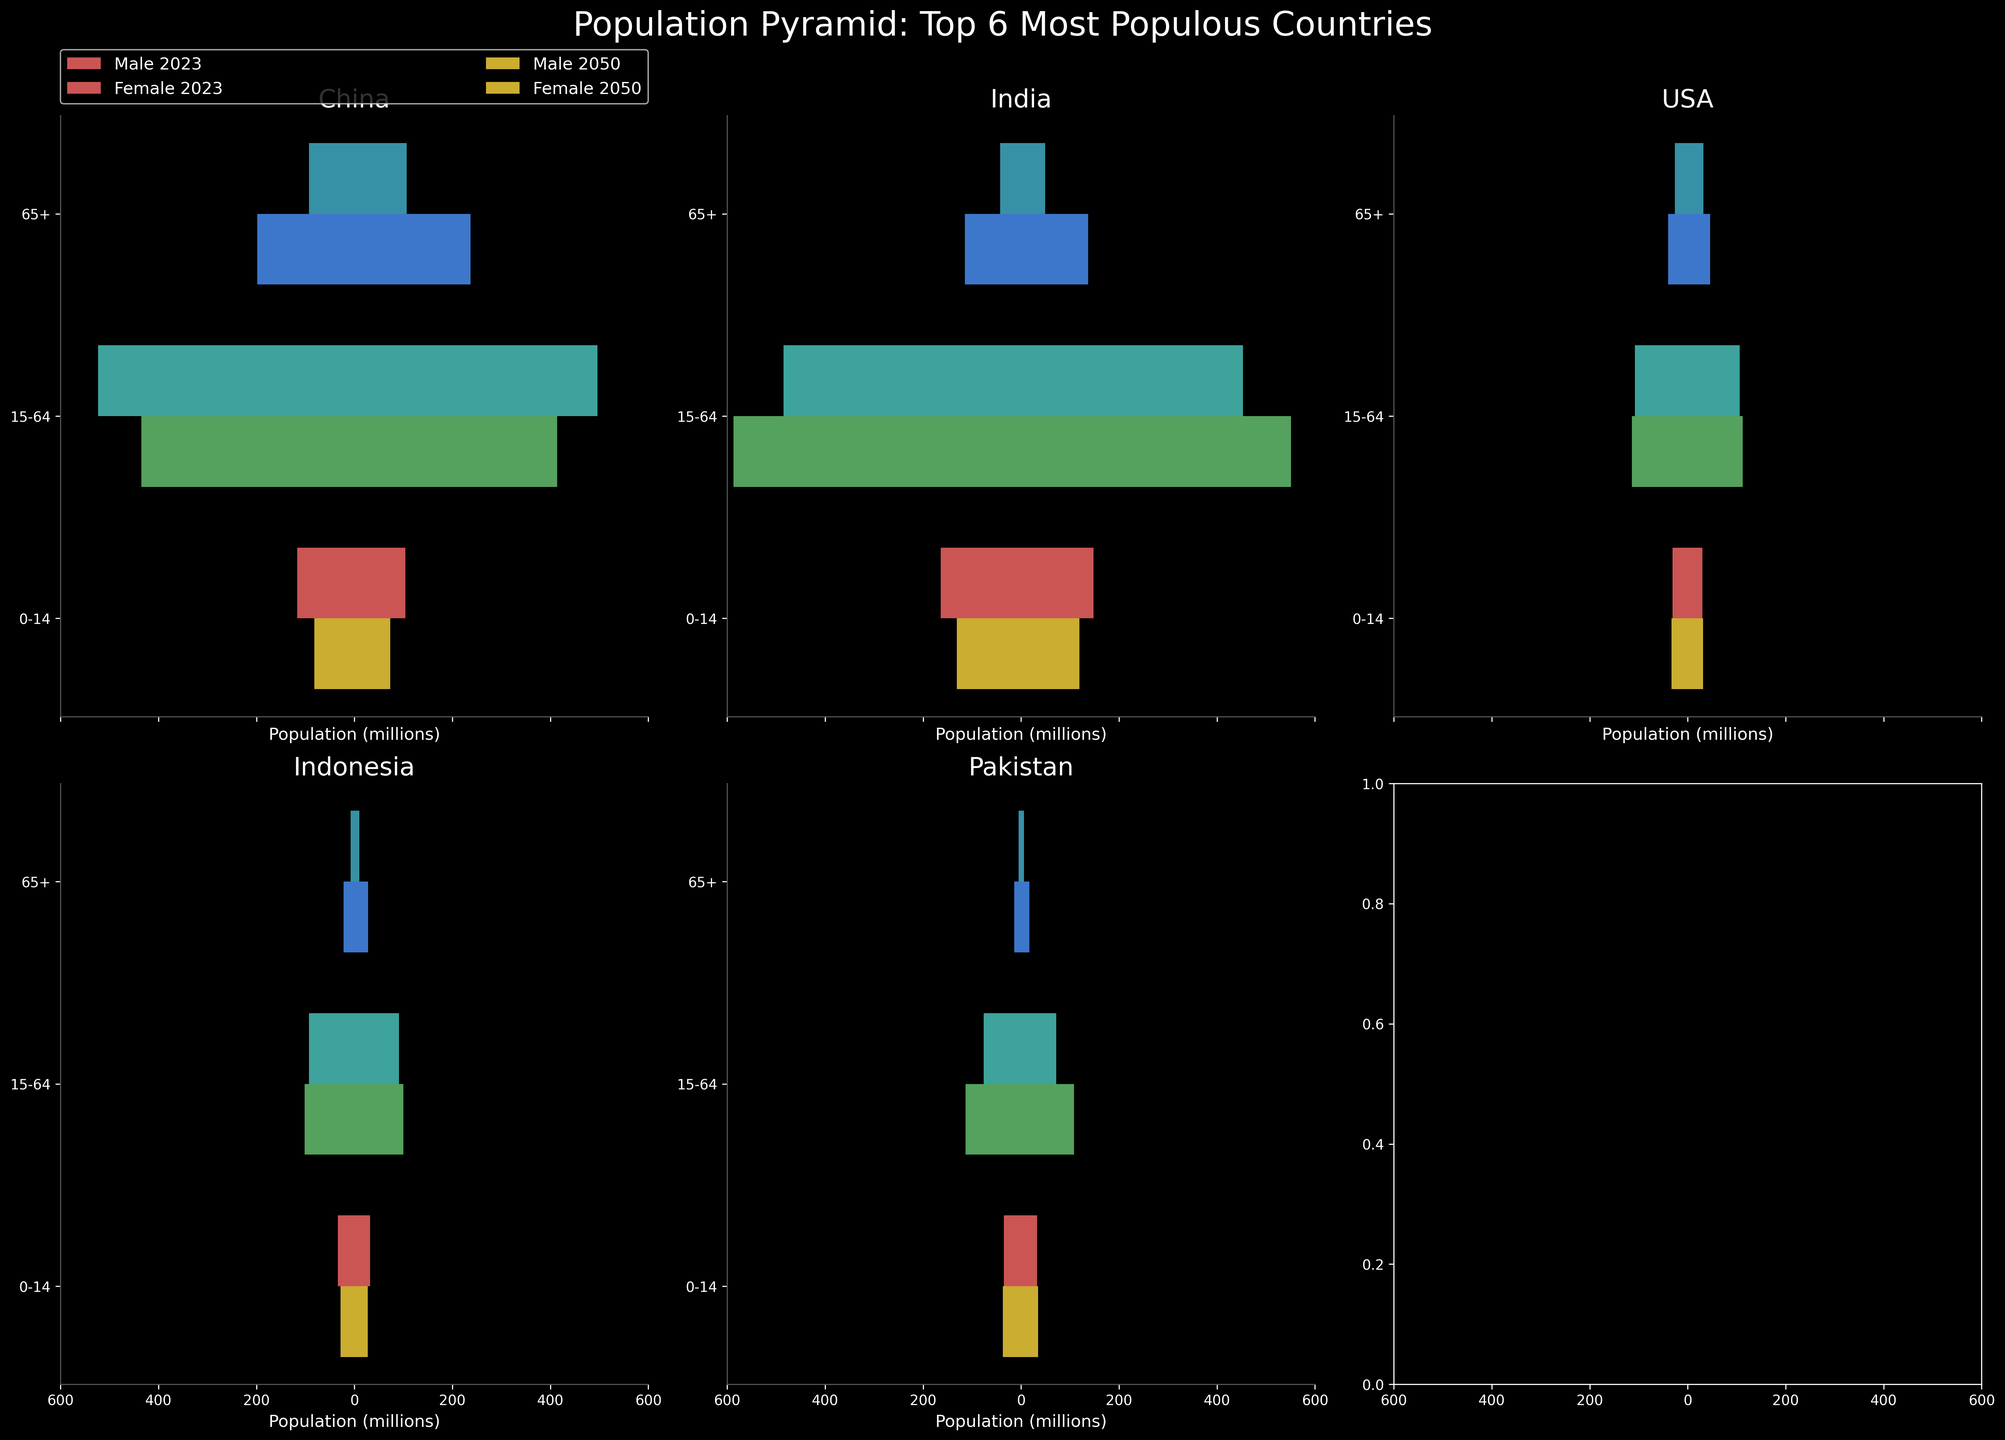What's the title of the figure? The title is centered at the top of the figure. It reads "Population Pyramid: Top 6 Most Populous Countries"
Answer: Population Pyramid: Top 6 Most Populous Countries How many age groups are displayed on the Y-axis? The Y-axis shows the different age groups. By counting the age groups, we see three distinct ones: "0-14", "15-64", and "65+"
Answer: 3 Which country has the highest projected male population aged 65+ in 2050? Among the countries displayed, the height of the bars for "Male 65+" in 2050 can be compared. India shows the tallest negative bar, indicating a higher male population among this age group.
Answer: India What’s the total population of China in 2023 in the age group 15-64? To find the total population, sum the male and female populations in the 15-64 age group for China in 2023. For males, it's 523 million, and for females, it's 496 million. Therefore, the total is 523 + 496 = 1019 million.
Answer: 1019 million Compare the projected populations of the USA in age group 0-14 for 2023 and 2050. Which year has a higher population, and by how much? Looking at the height of the bars for the USA in the 0-14 age group, 2050 has an approximate population of 33 million (males + females) while 2023 shows around 31 million. The difference is 33 - 31 = 2 million.
Answer: 2050, 2 million How does the female population aged 65+ in Pakistan in 2050 compare to that in 2023? Observing the bar lengths for "Female 65+" in Pakistan, the population in 2050 is significantly longer, at around 17 million, compared to only 6 million in 2023.
Answer: 2050 is higher by 11 million What trends can you observe in the aging population (65+) of China from 2023 to 2050? Comparing the heights of the bars for "65+" from 2023 to 2050 for China reveals that the population for both males and females significantly increases, indicating an aging population over time.
Answer: Increasing trend In which year does Indonesia have a higher male population in the age group 15-64, and by how much? By comparing the bar lengths for males aged 15-64 in Indonesia, the population in 2050 is about 102 million, whereas in 2023, it's around 93 million. The difference is 102 - 93 = 9 million.
Answer: 2050, by 9 million Which country has the smallest projected youth (0-14) population in 2050? By comparing the heights of the bars for the youth (0-14) category in 2050 across the countries, Indonesia shows the smallest combined length of bars for both genders.
Answer: Indonesia 